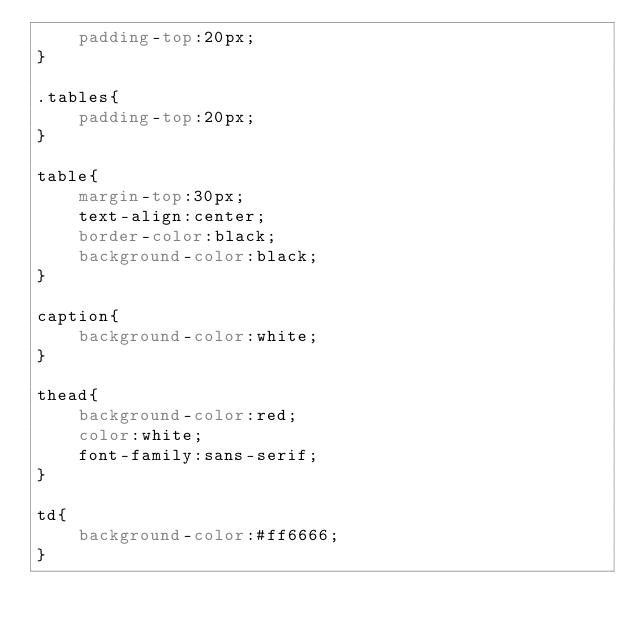<code> <loc_0><loc_0><loc_500><loc_500><_CSS_>	padding-top:20px;
}

.tables{
	padding-top:20px;
}

table{
	margin-top:30px;
	text-align:center;
	border-color:black;
	background-color:black;
}

caption{
	background-color:white;
}

thead{
	background-color:red;
	color:white;
	font-family:sans-serif;
}

td{
	background-color:#ff6666;
}</code> 